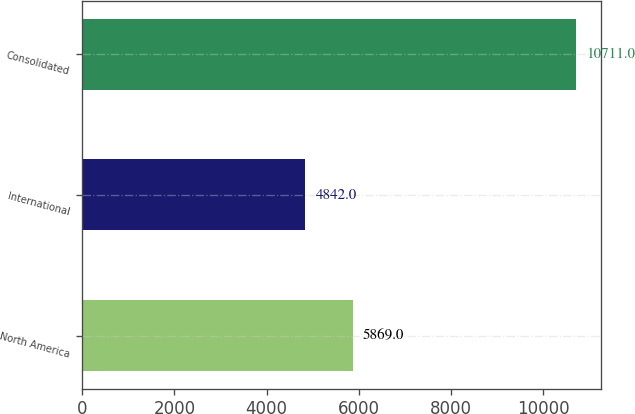Convert chart to OTSL. <chart><loc_0><loc_0><loc_500><loc_500><bar_chart><fcel>North America<fcel>International<fcel>Consolidated<nl><fcel>5869<fcel>4842<fcel>10711<nl></chart> 